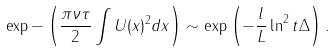Convert formula to latex. <formula><loc_0><loc_0><loc_500><loc_500>\exp - \left ( \frac { \pi \nu \tau } { 2 } \int U ( x ) ^ { 2 } d x \right ) \sim \exp \left ( - \frac { l } { L } \ln ^ { 2 } t \Delta \right ) .</formula> 